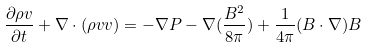Convert formula to latex. <formula><loc_0><loc_0><loc_500><loc_500>\frac { \partial \rho v } { \partial t } + \nabla \cdot ( \rho v v ) = - \nabla P - \nabla ( \frac { { B } ^ { 2 } } { 8 \pi } ) + \frac { 1 } { 4 \pi } ( B \cdot \nabla ) B</formula> 